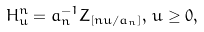<formula> <loc_0><loc_0><loc_500><loc_500>H _ { u } ^ { n } = a _ { n } ^ { - 1 } Z _ { [ n u / a _ { n } ] } , \, u \geq 0 ,</formula> 